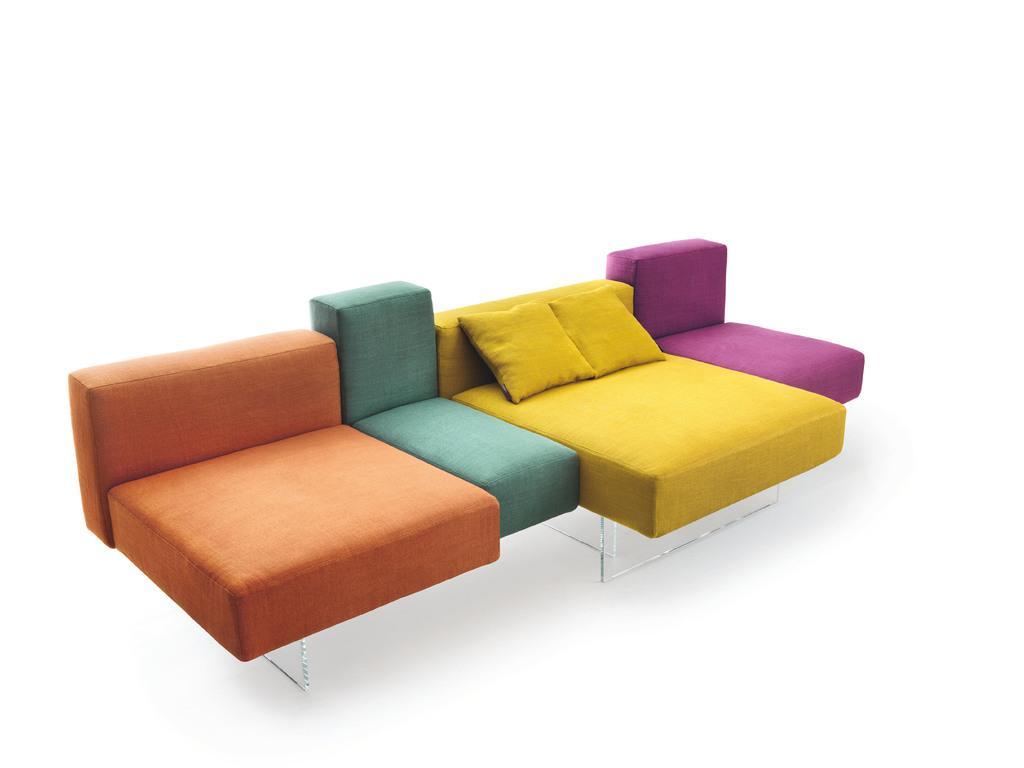Could you give a brief overview of what you see in this image? In this image I can see a couch and a pillows. There are in different color. There are in orange,blue,yellow and purple. 